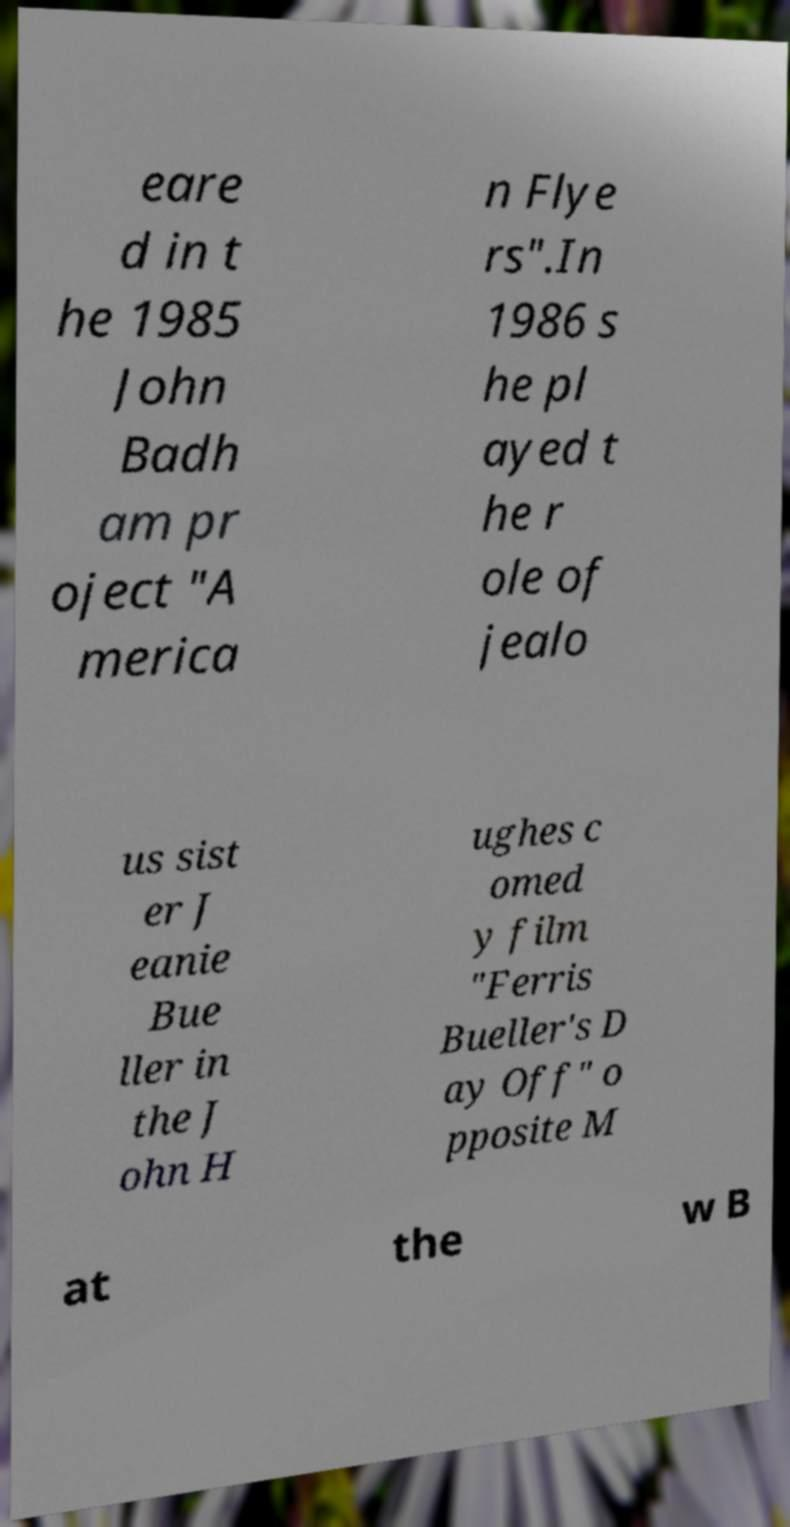Could you extract and type out the text from this image? eare d in t he 1985 John Badh am pr oject "A merica n Flye rs".In 1986 s he pl ayed t he r ole of jealo us sist er J eanie Bue ller in the J ohn H ughes c omed y film "Ferris Bueller's D ay Off" o pposite M at the w B 